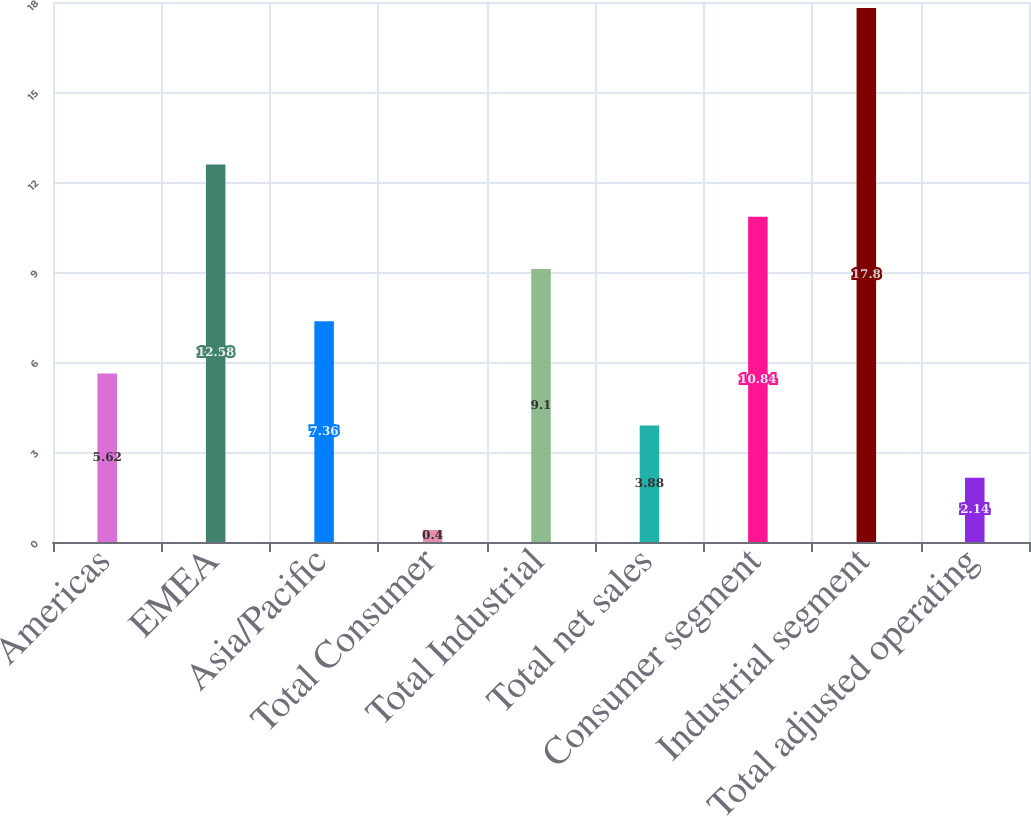<chart> <loc_0><loc_0><loc_500><loc_500><bar_chart><fcel>Americas<fcel>EMEA<fcel>Asia/Pacific<fcel>Total Consumer<fcel>Total Industrial<fcel>Total net sales<fcel>Consumer segment<fcel>Industrial segment<fcel>Total adjusted operating<nl><fcel>5.62<fcel>12.58<fcel>7.36<fcel>0.4<fcel>9.1<fcel>3.88<fcel>10.84<fcel>17.8<fcel>2.14<nl></chart> 